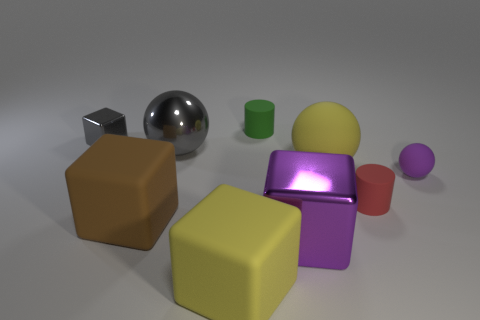How many other things are there of the same shape as the large brown rubber thing?
Your response must be concise. 3. There is a ball that is to the right of the tiny red matte thing that is in front of the large rubber thing that is behind the small red matte object; what size is it?
Make the answer very short. Small. Are there fewer big purple cubes in front of the big yellow block than large yellow matte things on the right side of the tiny green cylinder?
Offer a very short reply. Yes. How many tiny green things have the same material as the large gray object?
Make the answer very short. 0. Is there a tiny red matte cylinder right of the small rubber cylinder that is in front of the small matte object behind the tiny gray shiny cube?
Your response must be concise. No. The small green object that is the same material as the tiny purple sphere is what shape?
Provide a short and direct response. Cylinder. Is the number of yellow cubes greater than the number of tiny red metal cubes?
Give a very brief answer. Yes. Is the shape of the purple metal thing the same as the yellow rubber thing that is left of the yellow rubber sphere?
Your answer should be very brief. Yes. What material is the red thing?
Offer a terse response. Rubber. What is the color of the cylinder that is behind the matte ball that is in front of the yellow rubber thing that is behind the tiny sphere?
Your answer should be very brief. Green. 